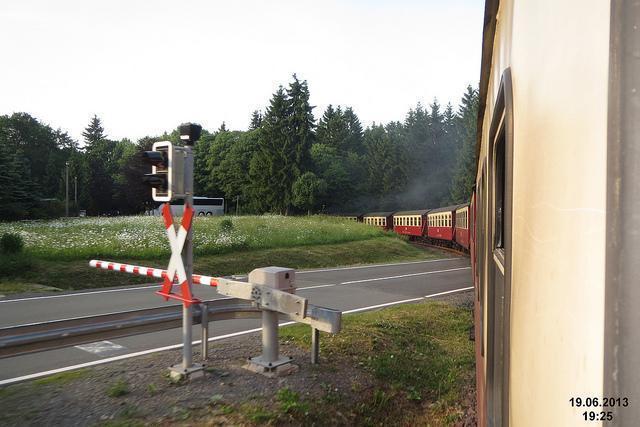What color is the area of the train car around the window?
Choose the right answer from the provided options to respond to the question.
Options: Orange, cream, white, pink. Cream. 